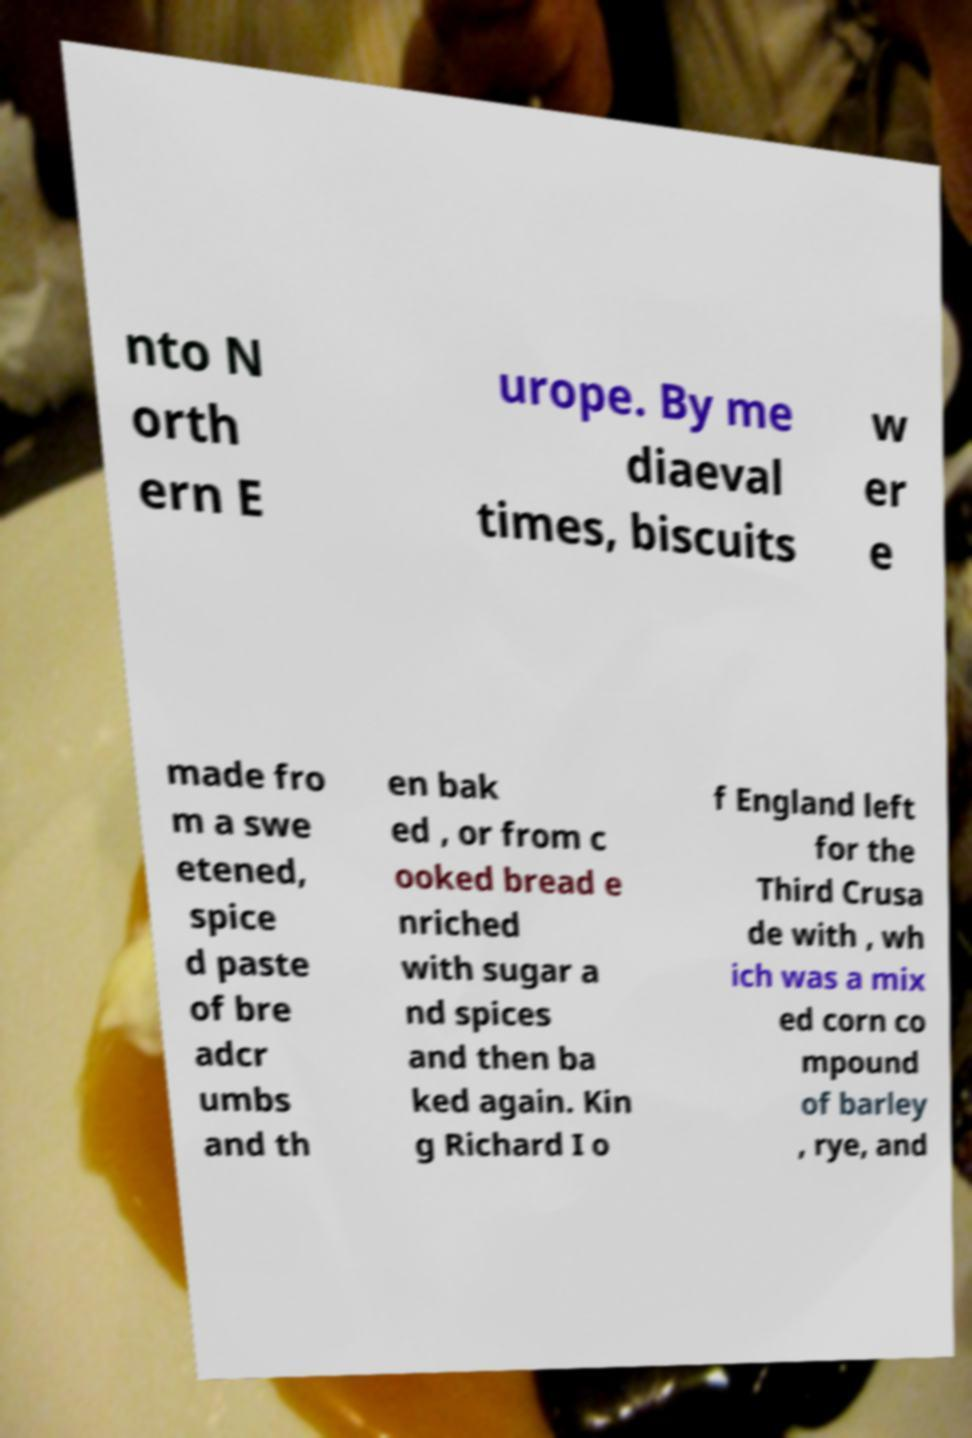What messages or text are displayed in this image? I need them in a readable, typed format. nto N orth ern E urope. By me diaeval times, biscuits w er e made fro m a swe etened, spice d paste of bre adcr umbs and th en bak ed , or from c ooked bread e nriched with sugar a nd spices and then ba ked again. Kin g Richard I o f England left for the Third Crusa de with , wh ich was a mix ed corn co mpound of barley , rye, and 